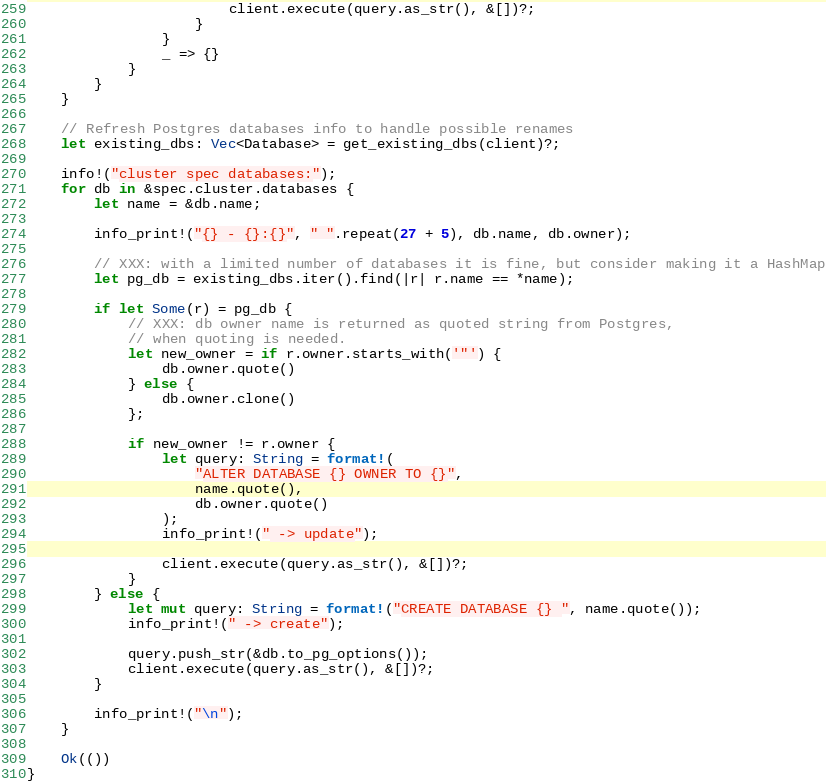<code> <loc_0><loc_0><loc_500><loc_500><_Rust_>                        client.execute(query.as_str(), &[])?;
                    }
                }
                _ => {}
            }
        }
    }

    // Refresh Postgres databases info to handle possible renames
    let existing_dbs: Vec<Database> = get_existing_dbs(client)?;

    info!("cluster spec databases:");
    for db in &spec.cluster.databases {
        let name = &db.name;

        info_print!("{} - {}:{}", " ".repeat(27 + 5), db.name, db.owner);

        // XXX: with a limited number of databases it is fine, but consider making it a HashMap
        let pg_db = existing_dbs.iter().find(|r| r.name == *name);

        if let Some(r) = pg_db {
            // XXX: db owner name is returned as quoted string from Postgres,
            // when quoting is needed.
            let new_owner = if r.owner.starts_with('"') {
                db.owner.quote()
            } else {
                db.owner.clone()
            };

            if new_owner != r.owner {
                let query: String = format!(
                    "ALTER DATABASE {} OWNER TO {}",
                    name.quote(),
                    db.owner.quote()
                );
                info_print!(" -> update");

                client.execute(query.as_str(), &[])?;
            }
        } else {
            let mut query: String = format!("CREATE DATABASE {} ", name.quote());
            info_print!(" -> create");

            query.push_str(&db.to_pg_options());
            client.execute(query.as_str(), &[])?;
        }

        info_print!("\n");
    }

    Ok(())
}
</code> 